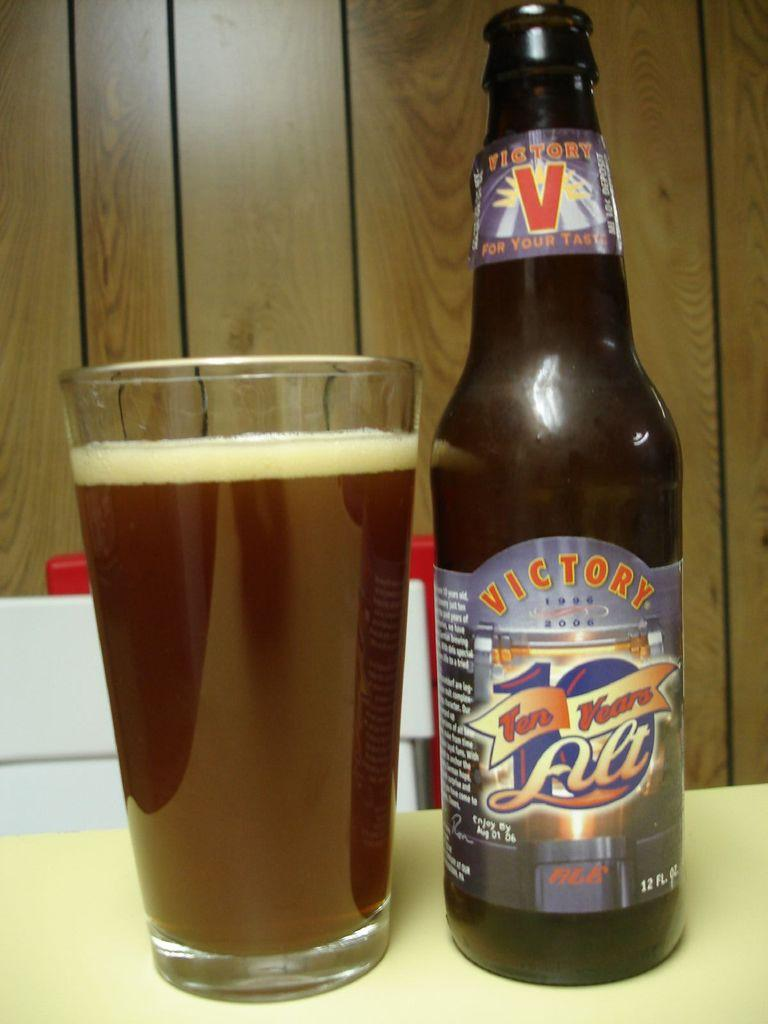<image>
Write a terse but informative summary of the picture. A bottle of 10 years Ale is next to a full glass of beer. 